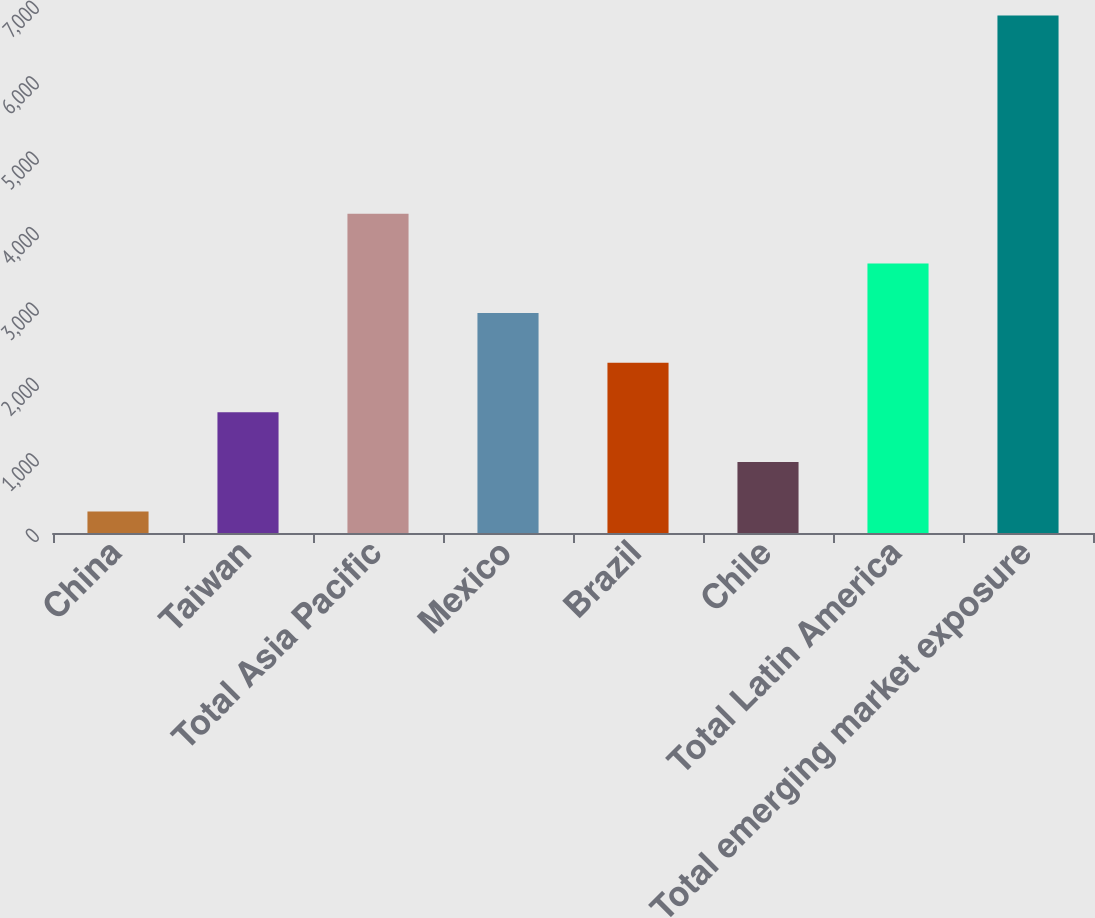<chart> <loc_0><loc_0><loc_500><loc_500><bar_chart><fcel>China<fcel>Taiwan<fcel>Total Asia Pacific<fcel>Mexico<fcel>Brazil<fcel>Chile<fcel>Total Latin America<fcel>Total emerging market exposure<nl><fcel>285<fcel>1600.4<fcel>4231.2<fcel>2915.8<fcel>2258.1<fcel>942.7<fcel>3573.5<fcel>6862<nl></chart> 